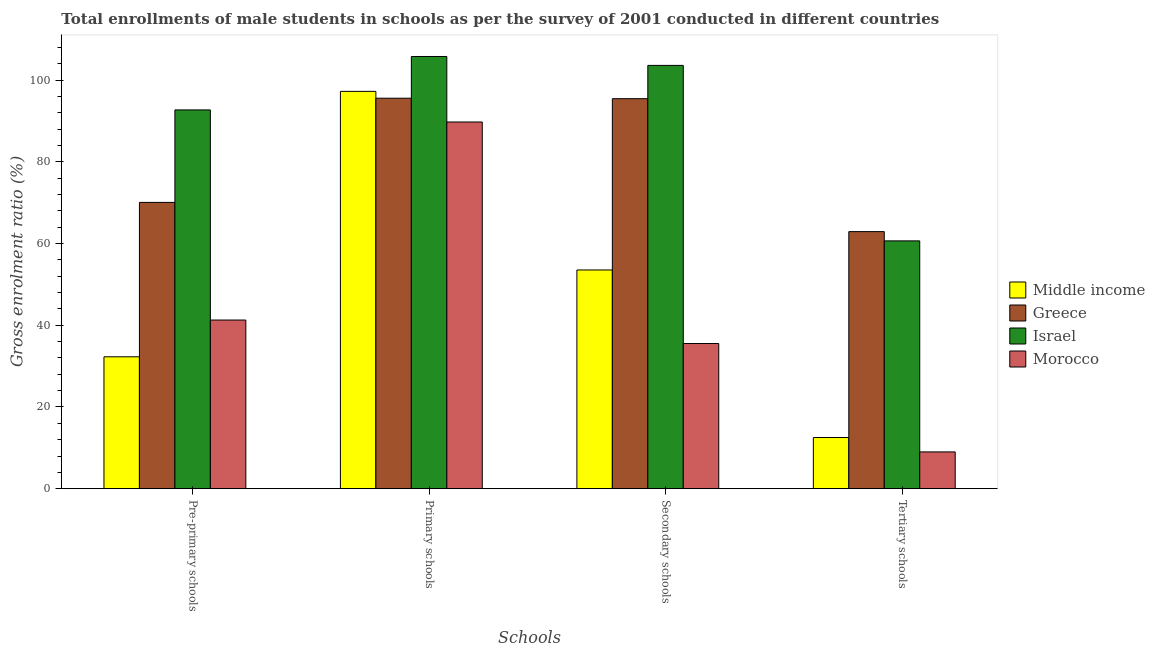Are the number of bars on each tick of the X-axis equal?
Your answer should be very brief. Yes. How many bars are there on the 2nd tick from the left?
Provide a short and direct response. 4. How many bars are there on the 1st tick from the right?
Offer a terse response. 4. What is the label of the 1st group of bars from the left?
Provide a short and direct response. Pre-primary schools. What is the gross enrolment ratio(male) in secondary schools in Middle income?
Provide a succinct answer. 53.55. Across all countries, what is the maximum gross enrolment ratio(male) in tertiary schools?
Your answer should be very brief. 62.95. Across all countries, what is the minimum gross enrolment ratio(male) in tertiary schools?
Give a very brief answer. 9. In which country was the gross enrolment ratio(male) in pre-primary schools minimum?
Provide a succinct answer. Middle income. What is the total gross enrolment ratio(male) in primary schools in the graph?
Give a very brief answer. 388.52. What is the difference between the gross enrolment ratio(male) in pre-primary schools in Israel and that in Greece?
Your answer should be compact. 22.64. What is the difference between the gross enrolment ratio(male) in secondary schools in Middle income and the gross enrolment ratio(male) in pre-primary schools in Morocco?
Give a very brief answer. 12.26. What is the average gross enrolment ratio(male) in tertiary schools per country?
Give a very brief answer. 36.29. What is the difference between the gross enrolment ratio(male) in secondary schools and gross enrolment ratio(male) in tertiary schools in Middle income?
Keep it short and to the point. 41.03. What is the ratio of the gross enrolment ratio(male) in secondary schools in Greece to that in Israel?
Provide a succinct answer. 0.92. What is the difference between the highest and the second highest gross enrolment ratio(male) in secondary schools?
Keep it short and to the point. 8.15. What is the difference between the highest and the lowest gross enrolment ratio(male) in pre-primary schools?
Offer a terse response. 60.46. In how many countries, is the gross enrolment ratio(male) in primary schools greater than the average gross enrolment ratio(male) in primary schools taken over all countries?
Provide a short and direct response. 2. What does the 3rd bar from the left in Tertiary schools represents?
Keep it short and to the point. Israel. What does the 3rd bar from the right in Tertiary schools represents?
Offer a very short reply. Greece. Is it the case that in every country, the sum of the gross enrolment ratio(male) in pre-primary schools and gross enrolment ratio(male) in primary schools is greater than the gross enrolment ratio(male) in secondary schools?
Your answer should be very brief. Yes. How many countries are there in the graph?
Offer a very short reply. 4. What is the difference between two consecutive major ticks on the Y-axis?
Make the answer very short. 20. Are the values on the major ticks of Y-axis written in scientific E-notation?
Provide a short and direct response. No. How are the legend labels stacked?
Provide a short and direct response. Vertical. What is the title of the graph?
Provide a short and direct response. Total enrollments of male students in schools as per the survey of 2001 conducted in different countries. Does "Myanmar" appear as one of the legend labels in the graph?
Make the answer very short. No. What is the label or title of the X-axis?
Make the answer very short. Schools. What is the label or title of the Y-axis?
Offer a very short reply. Gross enrolment ratio (%). What is the Gross enrolment ratio (%) of Middle income in Pre-primary schools?
Make the answer very short. 32.29. What is the Gross enrolment ratio (%) in Greece in Pre-primary schools?
Ensure brevity in your answer.  70.1. What is the Gross enrolment ratio (%) of Israel in Pre-primary schools?
Provide a succinct answer. 92.75. What is the Gross enrolment ratio (%) in Morocco in Pre-primary schools?
Provide a short and direct response. 41.29. What is the Gross enrolment ratio (%) in Middle income in Primary schools?
Offer a very short reply. 97.29. What is the Gross enrolment ratio (%) in Greece in Primary schools?
Ensure brevity in your answer.  95.61. What is the Gross enrolment ratio (%) in Israel in Primary schools?
Keep it short and to the point. 105.83. What is the Gross enrolment ratio (%) in Morocco in Primary schools?
Your answer should be very brief. 89.79. What is the Gross enrolment ratio (%) of Middle income in Secondary schools?
Give a very brief answer. 53.55. What is the Gross enrolment ratio (%) in Greece in Secondary schools?
Make the answer very short. 95.5. What is the Gross enrolment ratio (%) of Israel in Secondary schools?
Offer a very short reply. 103.65. What is the Gross enrolment ratio (%) in Morocco in Secondary schools?
Offer a very short reply. 35.54. What is the Gross enrolment ratio (%) in Middle income in Tertiary schools?
Ensure brevity in your answer.  12.53. What is the Gross enrolment ratio (%) in Greece in Tertiary schools?
Your answer should be compact. 62.95. What is the Gross enrolment ratio (%) of Israel in Tertiary schools?
Provide a succinct answer. 60.68. What is the Gross enrolment ratio (%) of Morocco in Tertiary schools?
Your answer should be compact. 9. Across all Schools, what is the maximum Gross enrolment ratio (%) in Middle income?
Your answer should be very brief. 97.29. Across all Schools, what is the maximum Gross enrolment ratio (%) in Greece?
Your answer should be very brief. 95.61. Across all Schools, what is the maximum Gross enrolment ratio (%) in Israel?
Ensure brevity in your answer.  105.83. Across all Schools, what is the maximum Gross enrolment ratio (%) of Morocco?
Ensure brevity in your answer.  89.79. Across all Schools, what is the minimum Gross enrolment ratio (%) of Middle income?
Your answer should be compact. 12.53. Across all Schools, what is the minimum Gross enrolment ratio (%) in Greece?
Give a very brief answer. 62.95. Across all Schools, what is the minimum Gross enrolment ratio (%) of Israel?
Give a very brief answer. 60.68. Across all Schools, what is the minimum Gross enrolment ratio (%) in Morocco?
Offer a terse response. 9. What is the total Gross enrolment ratio (%) in Middle income in the graph?
Provide a succinct answer. 195.66. What is the total Gross enrolment ratio (%) in Greece in the graph?
Offer a terse response. 324.16. What is the total Gross enrolment ratio (%) in Israel in the graph?
Your answer should be compact. 362.9. What is the total Gross enrolment ratio (%) in Morocco in the graph?
Give a very brief answer. 175.63. What is the difference between the Gross enrolment ratio (%) in Middle income in Pre-primary schools and that in Primary schools?
Your answer should be compact. -65. What is the difference between the Gross enrolment ratio (%) in Greece in Pre-primary schools and that in Primary schools?
Provide a short and direct response. -25.51. What is the difference between the Gross enrolment ratio (%) in Israel in Pre-primary schools and that in Primary schools?
Your response must be concise. -13.08. What is the difference between the Gross enrolment ratio (%) in Morocco in Pre-primary schools and that in Primary schools?
Provide a succinct answer. -48.5. What is the difference between the Gross enrolment ratio (%) in Middle income in Pre-primary schools and that in Secondary schools?
Give a very brief answer. -21.26. What is the difference between the Gross enrolment ratio (%) of Greece in Pre-primary schools and that in Secondary schools?
Give a very brief answer. -25.4. What is the difference between the Gross enrolment ratio (%) of Israel in Pre-primary schools and that in Secondary schools?
Provide a short and direct response. -10.9. What is the difference between the Gross enrolment ratio (%) in Morocco in Pre-primary schools and that in Secondary schools?
Provide a succinct answer. 5.75. What is the difference between the Gross enrolment ratio (%) in Middle income in Pre-primary schools and that in Tertiary schools?
Provide a succinct answer. 19.77. What is the difference between the Gross enrolment ratio (%) in Greece in Pre-primary schools and that in Tertiary schools?
Make the answer very short. 7.16. What is the difference between the Gross enrolment ratio (%) in Israel in Pre-primary schools and that in Tertiary schools?
Make the answer very short. 32.07. What is the difference between the Gross enrolment ratio (%) of Morocco in Pre-primary schools and that in Tertiary schools?
Your answer should be compact. 32.29. What is the difference between the Gross enrolment ratio (%) of Middle income in Primary schools and that in Secondary schools?
Give a very brief answer. 43.73. What is the difference between the Gross enrolment ratio (%) in Greece in Primary schools and that in Secondary schools?
Give a very brief answer. 0.11. What is the difference between the Gross enrolment ratio (%) of Israel in Primary schools and that in Secondary schools?
Give a very brief answer. 2.18. What is the difference between the Gross enrolment ratio (%) in Morocco in Primary schools and that in Secondary schools?
Provide a short and direct response. 54.25. What is the difference between the Gross enrolment ratio (%) of Middle income in Primary schools and that in Tertiary schools?
Ensure brevity in your answer.  84.76. What is the difference between the Gross enrolment ratio (%) in Greece in Primary schools and that in Tertiary schools?
Provide a short and direct response. 32.67. What is the difference between the Gross enrolment ratio (%) in Israel in Primary schools and that in Tertiary schools?
Make the answer very short. 45.15. What is the difference between the Gross enrolment ratio (%) of Morocco in Primary schools and that in Tertiary schools?
Provide a succinct answer. 80.79. What is the difference between the Gross enrolment ratio (%) of Middle income in Secondary schools and that in Tertiary schools?
Provide a short and direct response. 41.03. What is the difference between the Gross enrolment ratio (%) in Greece in Secondary schools and that in Tertiary schools?
Your answer should be compact. 32.55. What is the difference between the Gross enrolment ratio (%) of Israel in Secondary schools and that in Tertiary schools?
Offer a terse response. 42.97. What is the difference between the Gross enrolment ratio (%) of Morocco in Secondary schools and that in Tertiary schools?
Your response must be concise. 26.54. What is the difference between the Gross enrolment ratio (%) of Middle income in Pre-primary schools and the Gross enrolment ratio (%) of Greece in Primary schools?
Give a very brief answer. -63.32. What is the difference between the Gross enrolment ratio (%) of Middle income in Pre-primary schools and the Gross enrolment ratio (%) of Israel in Primary schools?
Make the answer very short. -73.54. What is the difference between the Gross enrolment ratio (%) in Middle income in Pre-primary schools and the Gross enrolment ratio (%) in Morocco in Primary schools?
Ensure brevity in your answer.  -57.5. What is the difference between the Gross enrolment ratio (%) of Greece in Pre-primary schools and the Gross enrolment ratio (%) of Israel in Primary schools?
Keep it short and to the point. -35.73. What is the difference between the Gross enrolment ratio (%) in Greece in Pre-primary schools and the Gross enrolment ratio (%) in Morocco in Primary schools?
Ensure brevity in your answer.  -19.69. What is the difference between the Gross enrolment ratio (%) of Israel in Pre-primary schools and the Gross enrolment ratio (%) of Morocco in Primary schools?
Your answer should be compact. 2.96. What is the difference between the Gross enrolment ratio (%) of Middle income in Pre-primary schools and the Gross enrolment ratio (%) of Greece in Secondary schools?
Keep it short and to the point. -63.21. What is the difference between the Gross enrolment ratio (%) of Middle income in Pre-primary schools and the Gross enrolment ratio (%) of Israel in Secondary schools?
Provide a succinct answer. -71.36. What is the difference between the Gross enrolment ratio (%) in Middle income in Pre-primary schools and the Gross enrolment ratio (%) in Morocco in Secondary schools?
Give a very brief answer. -3.25. What is the difference between the Gross enrolment ratio (%) in Greece in Pre-primary schools and the Gross enrolment ratio (%) in Israel in Secondary schools?
Keep it short and to the point. -33.55. What is the difference between the Gross enrolment ratio (%) in Greece in Pre-primary schools and the Gross enrolment ratio (%) in Morocco in Secondary schools?
Your answer should be compact. 34.56. What is the difference between the Gross enrolment ratio (%) in Israel in Pre-primary schools and the Gross enrolment ratio (%) in Morocco in Secondary schools?
Offer a terse response. 57.21. What is the difference between the Gross enrolment ratio (%) in Middle income in Pre-primary schools and the Gross enrolment ratio (%) in Greece in Tertiary schools?
Make the answer very short. -30.65. What is the difference between the Gross enrolment ratio (%) of Middle income in Pre-primary schools and the Gross enrolment ratio (%) of Israel in Tertiary schools?
Your answer should be compact. -28.39. What is the difference between the Gross enrolment ratio (%) of Middle income in Pre-primary schools and the Gross enrolment ratio (%) of Morocco in Tertiary schools?
Provide a succinct answer. 23.29. What is the difference between the Gross enrolment ratio (%) in Greece in Pre-primary schools and the Gross enrolment ratio (%) in Israel in Tertiary schools?
Provide a succinct answer. 9.42. What is the difference between the Gross enrolment ratio (%) in Greece in Pre-primary schools and the Gross enrolment ratio (%) in Morocco in Tertiary schools?
Your answer should be compact. 61.1. What is the difference between the Gross enrolment ratio (%) in Israel in Pre-primary schools and the Gross enrolment ratio (%) in Morocco in Tertiary schools?
Provide a succinct answer. 83.75. What is the difference between the Gross enrolment ratio (%) of Middle income in Primary schools and the Gross enrolment ratio (%) of Greece in Secondary schools?
Ensure brevity in your answer.  1.79. What is the difference between the Gross enrolment ratio (%) in Middle income in Primary schools and the Gross enrolment ratio (%) in Israel in Secondary schools?
Your answer should be compact. -6.36. What is the difference between the Gross enrolment ratio (%) of Middle income in Primary schools and the Gross enrolment ratio (%) of Morocco in Secondary schools?
Ensure brevity in your answer.  61.75. What is the difference between the Gross enrolment ratio (%) of Greece in Primary schools and the Gross enrolment ratio (%) of Israel in Secondary schools?
Make the answer very short. -8.04. What is the difference between the Gross enrolment ratio (%) of Greece in Primary schools and the Gross enrolment ratio (%) of Morocco in Secondary schools?
Your answer should be compact. 60.07. What is the difference between the Gross enrolment ratio (%) of Israel in Primary schools and the Gross enrolment ratio (%) of Morocco in Secondary schools?
Provide a succinct answer. 70.29. What is the difference between the Gross enrolment ratio (%) in Middle income in Primary schools and the Gross enrolment ratio (%) in Greece in Tertiary schools?
Keep it short and to the point. 34.34. What is the difference between the Gross enrolment ratio (%) in Middle income in Primary schools and the Gross enrolment ratio (%) in Israel in Tertiary schools?
Give a very brief answer. 36.61. What is the difference between the Gross enrolment ratio (%) in Middle income in Primary schools and the Gross enrolment ratio (%) in Morocco in Tertiary schools?
Provide a short and direct response. 88.29. What is the difference between the Gross enrolment ratio (%) of Greece in Primary schools and the Gross enrolment ratio (%) of Israel in Tertiary schools?
Your response must be concise. 34.93. What is the difference between the Gross enrolment ratio (%) in Greece in Primary schools and the Gross enrolment ratio (%) in Morocco in Tertiary schools?
Ensure brevity in your answer.  86.61. What is the difference between the Gross enrolment ratio (%) of Israel in Primary schools and the Gross enrolment ratio (%) of Morocco in Tertiary schools?
Make the answer very short. 96.83. What is the difference between the Gross enrolment ratio (%) of Middle income in Secondary schools and the Gross enrolment ratio (%) of Greece in Tertiary schools?
Offer a very short reply. -9.39. What is the difference between the Gross enrolment ratio (%) of Middle income in Secondary schools and the Gross enrolment ratio (%) of Israel in Tertiary schools?
Offer a very short reply. -7.12. What is the difference between the Gross enrolment ratio (%) of Middle income in Secondary schools and the Gross enrolment ratio (%) of Morocco in Tertiary schools?
Offer a very short reply. 44.55. What is the difference between the Gross enrolment ratio (%) in Greece in Secondary schools and the Gross enrolment ratio (%) in Israel in Tertiary schools?
Your answer should be compact. 34.82. What is the difference between the Gross enrolment ratio (%) of Greece in Secondary schools and the Gross enrolment ratio (%) of Morocco in Tertiary schools?
Ensure brevity in your answer.  86.5. What is the difference between the Gross enrolment ratio (%) in Israel in Secondary schools and the Gross enrolment ratio (%) in Morocco in Tertiary schools?
Offer a terse response. 94.65. What is the average Gross enrolment ratio (%) in Middle income per Schools?
Provide a short and direct response. 48.91. What is the average Gross enrolment ratio (%) of Greece per Schools?
Keep it short and to the point. 81.04. What is the average Gross enrolment ratio (%) of Israel per Schools?
Keep it short and to the point. 90.73. What is the average Gross enrolment ratio (%) in Morocco per Schools?
Your response must be concise. 43.91. What is the difference between the Gross enrolment ratio (%) of Middle income and Gross enrolment ratio (%) of Greece in Pre-primary schools?
Ensure brevity in your answer.  -37.81. What is the difference between the Gross enrolment ratio (%) of Middle income and Gross enrolment ratio (%) of Israel in Pre-primary schools?
Your response must be concise. -60.46. What is the difference between the Gross enrolment ratio (%) of Middle income and Gross enrolment ratio (%) of Morocco in Pre-primary schools?
Your answer should be very brief. -9. What is the difference between the Gross enrolment ratio (%) in Greece and Gross enrolment ratio (%) in Israel in Pre-primary schools?
Provide a succinct answer. -22.64. What is the difference between the Gross enrolment ratio (%) in Greece and Gross enrolment ratio (%) in Morocco in Pre-primary schools?
Give a very brief answer. 28.81. What is the difference between the Gross enrolment ratio (%) of Israel and Gross enrolment ratio (%) of Morocco in Pre-primary schools?
Your answer should be very brief. 51.45. What is the difference between the Gross enrolment ratio (%) of Middle income and Gross enrolment ratio (%) of Greece in Primary schools?
Offer a terse response. 1.67. What is the difference between the Gross enrolment ratio (%) of Middle income and Gross enrolment ratio (%) of Israel in Primary schools?
Your response must be concise. -8.54. What is the difference between the Gross enrolment ratio (%) of Middle income and Gross enrolment ratio (%) of Morocco in Primary schools?
Offer a terse response. 7.5. What is the difference between the Gross enrolment ratio (%) of Greece and Gross enrolment ratio (%) of Israel in Primary schools?
Make the answer very short. -10.22. What is the difference between the Gross enrolment ratio (%) of Greece and Gross enrolment ratio (%) of Morocco in Primary schools?
Make the answer very short. 5.82. What is the difference between the Gross enrolment ratio (%) in Israel and Gross enrolment ratio (%) in Morocco in Primary schools?
Offer a terse response. 16.04. What is the difference between the Gross enrolment ratio (%) in Middle income and Gross enrolment ratio (%) in Greece in Secondary schools?
Your response must be concise. -41.94. What is the difference between the Gross enrolment ratio (%) in Middle income and Gross enrolment ratio (%) in Israel in Secondary schools?
Make the answer very short. -50.09. What is the difference between the Gross enrolment ratio (%) of Middle income and Gross enrolment ratio (%) of Morocco in Secondary schools?
Provide a short and direct response. 18.01. What is the difference between the Gross enrolment ratio (%) of Greece and Gross enrolment ratio (%) of Israel in Secondary schools?
Offer a terse response. -8.15. What is the difference between the Gross enrolment ratio (%) of Greece and Gross enrolment ratio (%) of Morocco in Secondary schools?
Offer a very short reply. 59.96. What is the difference between the Gross enrolment ratio (%) in Israel and Gross enrolment ratio (%) in Morocco in Secondary schools?
Your response must be concise. 68.11. What is the difference between the Gross enrolment ratio (%) in Middle income and Gross enrolment ratio (%) in Greece in Tertiary schools?
Your response must be concise. -50.42. What is the difference between the Gross enrolment ratio (%) in Middle income and Gross enrolment ratio (%) in Israel in Tertiary schools?
Make the answer very short. -48.15. What is the difference between the Gross enrolment ratio (%) of Middle income and Gross enrolment ratio (%) of Morocco in Tertiary schools?
Keep it short and to the point. 3.52. What is the difference between the Gross enrolment ratio (%) of Greece and Gross enrolment ratio (%) of Israel in Tertiary schools?
Offer a very short reply. 2.27. What is the difference between the Gross enrolment ratio (%) in Greece and Gross enrolment ratio (%) in Morocco in Tertiary schools?
Make the answer very short. 53.94. What is the difference between the Gross enrolment ratio (%) of Israel and Gross enrolment ratio (%) of Morocco in Tertiary schools?
Your response must be concise. 51.68. What is the ratio of the Gross enrolment ratio (%) of Middle income in Pre-primary schools to that in Primary schools?
Offer a very short reply. 0.33. What is the ratio of the Gross enrolment ratio (%) of Greece in Pre-primary schools to that in Primary schools?
Your response must be concise. 0.73. What is the ratio of the Gross enrolment ratio (%) of Israel in Pre-primary schools to that in Primary schools?
Your response must be concise. 0.88. What is the ratio of the Gross enrolment ratio (%) of Morocco in Pre-primary schools to that in Primary schools?
Provide a succinct answer. 0.46. What is the ratio of the Gross enrolment ratio (%) of Middle income in Pre-primary schools to that in Secondary schools?
Your answer should be compact. 0.6. What is the ratio of the Gross enrolment ratio (%) of Greece in Pre-primary schools to that in Secondary schools?
Your response must be concise. 0.73. What is the ratio of the Gross enrolment ratio (%) in Israel in Pre-primary schools to that in Secondary schools?
Make the answer very short. 0.89. What is the ratio of the Gross enrolment ratio (%) of Morocco in Pre-primary schools to that in Secondary schools?
Make the answer very short. 1.16. What is the ratio of the Gross enrolment ratio (%) of Middle income in Pre-primary schools to that in Tertiary schools?
Your answer should be compact. 2.58. What is the ratio of the Gross enrolment ratio (%) of Greece in Pre-primary schools to that in Tertiary schools?
Provide a succinct answer. 1.11. What is the ratio of the Gross enrolment ratio (%) of Israel in Pre-primary schools to that in Tertiary schools?
Provide a succinct answer. 1.53. What is the ratio of the Gross enrolment ratio (%) of Morocco in Pre-primary schools to that in Tertiary schools?
Offer a very short reply. 4.59. What is the ratio of the Gross enrolment ratio (%) in Middle income in Primary schools to that in Secondary schools?
Make the answer very short. 1.82. What is the ratio of the Gross enrolment ratio (%) of Israel in Primary schools to that in Secondary schools?
Your response must be concise. 1.02. What is the ratio of the Gross enrolment ratio (%) in Morocco in Primary schools to that in Secondary schools?
Provide a short and direct response. 2.53. What is the ratio of the Gross enrolment ratio (%) of Middle income in Primary schools to that in Tertiary schools?
Provide a succinct answer. 7.77. What is the ratio of the Gross enrolment ratio (%) in Greece in Primary schools to that in Tertiary schools?
Your answer should be very brief. 1.52. What is the ratio of the Gross enrolment ratio (%) of Israel in Primary schools to that in Tertiary schools?
Keep it short and to the point. 1.74. What is the ratio of the Gross enrolment ratio (%) of Morocco in Primary schools to that in Tertiary schools?
Your response must be concise. 9.97. What is the ratio of the Gross enrolment ratio (%) of Middle income in Secondary schools to that in Tertiary schools?
Your response must be concise. 4.28. What is the ratio of the Gross enrolment ratio (%) in Greece in Secondary schools to that in Tertiary schools?
Your answer should be very brief. 1.52. What is the ratio of the Gross enrolment ratio (%) in Israel in Secondary schools to that in Tertiary schools?
Your answer should be compact. 1.71. What is the ratio of the Gross enrolment ratio (%) of Morocco in Secondary schools to that in Tertiary schools?
Give a very brief answer. 3.95. What is the difference between the highest and the second highest Gross enrolment ratio (%) in Middle income?
Your answer should be compact. 43.73. What is the difference between the highest and the second highest Gross enrolment ratio (%) in Greece?
Your response must be concise. 0.11. What is the difference between the highest and the second highest Gross enrolment ratio (%) in Israel?
Offer a very short reply. 2.18. What is the difference between the highest and the second highest Gross enrolment ratio (%) of Morocco?
Provide a short and direct response. 48.5. What is the difference between the highest and the lowest Gross enrolment ratio (%) in Middle income?
Offer a very short reply. 84.76. What is the difference between the highest and the lowest Gross enrolment ratio (%) in Greece?
Your response must be concise. 32.67. What is the difference between the highest and the lowest Gross enrolment ratio (%) in Israel?
Offer a terse response. 45.15. What is the difference between the highest and the lowest Gross enrolment ratio (%) in Morocco?
Give a very brief answer. 80.79. 